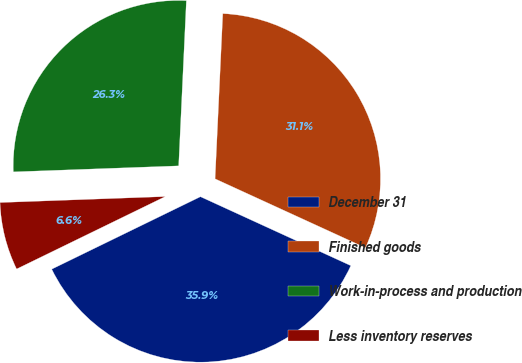<chart> <loc_0><loc_0><loc_500><loc_500><pie_chart><fcel>December 31<fcel>Finished goods<fcel>Work-in-process and production<fcel>Less inventory reserves<nl><fcel>35.94%<fcel>31.1%<fcel>26.32%<fcel>6.64%<nl></chart> 